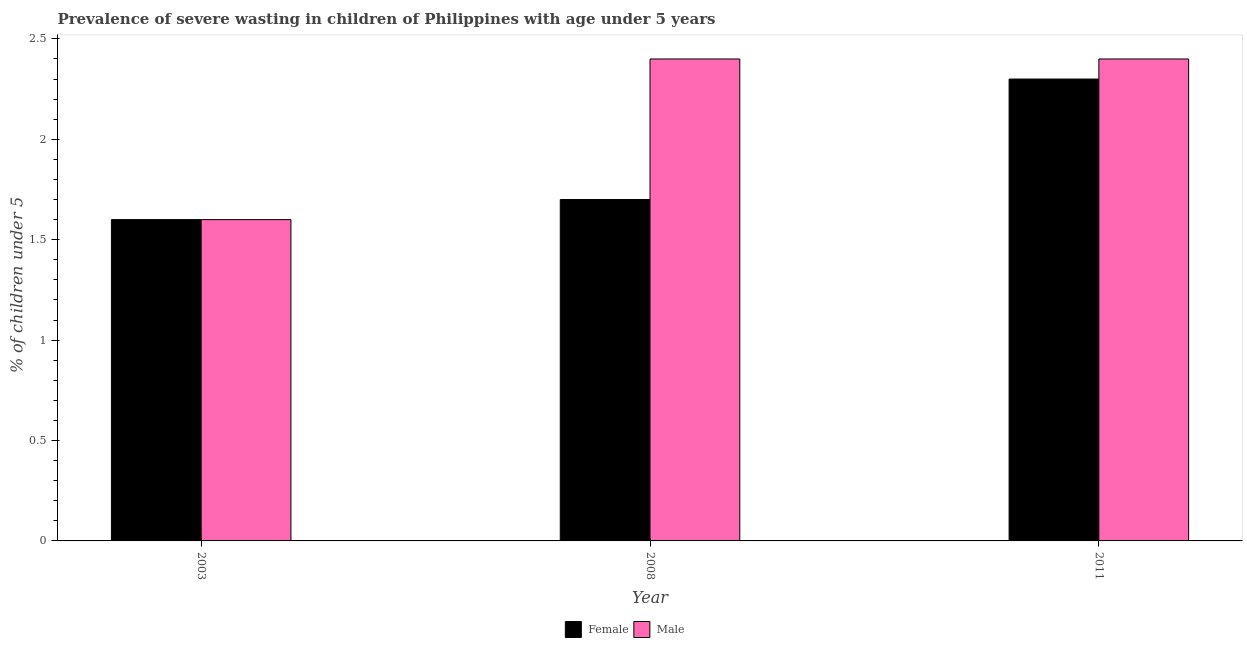Are the number of bars per tick equal to the number of legend labels?
Your response must be concise. Yes. How many bars are there on the 2nd tick from the left?
Offer a terse response. 2. What is the label of the 3rd group of bars from the left?
Your answer should be very brief. 2011. In how many cases, is the number of bars for a given year not equal to the number of legend labels?
Offer a very short reply. 0. What is the percentage of undernourished male children in 2003?
Offer a terse response. 1.6. Across all years, what is the maximum percentage of undernourished female children?
Make the answer very short. 2.3. Across all years, what is the minimum percentage of undernourished male children?
Offer a very short reply. 1.6. In which year was the percentage of undernourished male children minimum?
Keep it short and to the point. 2003. What is the total percentage of undernourished male children in the graph?
Provide a short and direct response. 6.4. What is the difference between the percentage of undernourished female children in 2003 and that in 2008?
Give a very brief answer. -0.1. What is the difference between the percentage of undernourished female children in 2011 and the percentage of undernourished male children in 2003?
Make the answer very short. 0.7. What is the average percentage of undernourished female children per year?
Offer a terse response. 1.87. In the year 2011, what is the difference between the percentage of undernourished female children and percentage of undernourished male children?
Provide a succinct answer. 0. What is the ratio of the percentage of undernourished female children in 2008 to that in 2011?
Keep it short and to the point. 0.74. Is the percentage of undernourished male children in 2008 less than that in 2011?
Provide a short and direct response. No. Is the difference between the percentage of undernourished male children in 2003 and 2011 greater than the difference between the percentage of undernourished female children in 2003 and 2011?
Provide a short and direct response. No. What is the difference between the highest and the lowest percentage of undernourished female children?
Your answer should be very brief. 0.7. In how many years, is the percentage of undernourished male children greater than the average percentage of undernourished male children taken over all years?
Your answer should be very brief. 2. Is the sum of the percentage of undernourished male children in 2003 and 2011 greater than the maximum percentage of undernourished female children across all years?
Offer a very short reply. Yes. What does the 1st bar from the left in 2003 represents?
Your answer should be very brief. Female. What does the 2nd bar from the right in 2008 represents?
Provide a succinct answer. Female. How many bars are there?
Keep it short and to the point. 6. Are all the bars in the graph horizontal?
Provide a short and direct response. No. How many years are there in the graph?
Offer a terse response. 3. Are the values on the major ticks of Y-axis written in scientific E-notation?
Ensure brevity in your answer.  No. Does the graph contain any zero values?
Your answer should be compact. No. Where does the legend appear in the graph?
Keep it short and to the point. Bottom center. What is the title of the graph?
Provide a short and direct response. Prevalence of severe wasting in children of Philippines with age under 5 years. What is the label or title of the X-axis?
Your answer should be very brief. Year. What is the label or title of the Y-axis?
Your answer should be compact.  % of children under 5. What is the  % of children under 5 of Female in 2003?
Your response must be concise. 1.6. What is the  % of children under 5 in Male in 2003?
Keep it short and to the point. 1.6. What is the  % of children under 5 in Female in 2008?
Provide a short and direct response. 1.7. What is the  % of children under 5 in Male in 2008?
Give a very brief answer. 2.4. What is the  % of children under 5 of Female in 2011?
Provide a succinct answer. 2.3. What is the  % of children under 5 of Male in 2011?
Offer a very short reply. 2.4. Across all years, what is the maximum  % of children under 5 in Female?
Make the answer very short. 2.3. Across all years, what is the maximum  % of children under 5 in Male?
Offer a very short reply. 2.4. Across all years, what is the minimum  % of children under 5 of Female?
Your answer should be compact. 1.6. Across all years, what is the minimum  % of children under 5 in Male?
Make the answer very short. 1.6. What is the total  % of children under 5 in Male in the graph?
Give a very brief answer. 6.4. What is the difference between the  % of children under 5 of Female in 2003 and that in 2008?
Your response must be concise. -0.1. What is the difference between the  % of children under 5 of Female in 2003 and that in 2011?
Provide a short and direct response. -0.7. What is the difference between the  % of children under 5 in Male in 2003 and that in 2011?
Keep it short and to the point. -0.8. What is the difference between the  % of children under 5 in Male in 2008 and that in 2011?
Provide a succinct answer. 0. What is the difference between the  % of children under 5 of Female in 2003 and the  % of children under 5 of Male in 2008?
Provide a succinct answer. -0.8. What is the difference between the  % of children under 5 of Female in 2003 and the  % of children under 5 of Male in 2011?
Make the answer very short. -0.8. What is the difference between the  % of children under 5 of Female in 2008 and the  % of children under 5 of Male in 2011?
Ensure brevity in your answer.  -0.7. What is the average  % of children under 5 in Female per year?
Your response must be concise. 1.87. What is the average  % of children under 5 in Male per year?
Offer a terse response. 2.13. In the year 2003, what is the difference between the  % of children under 5 of Female and  % of children under 5 of Male?
Give a very brief answer. 0. What is the ratio of the  % of children under 5 in Female in 2003 to that in 2008?
Your response must be concise. 0.94. What is the ratio of the  % of children under 5 of Female in 2003 to that in 2011?
Provide a succinct answer. 0.7. What is the ratio of the  % of children under 5 of Female in 2008 to that in 2011?
Your answer should be compact. 0.74. What is the ratio of the  % of children under 5 in Male in 2008 to that in 2011?
Your answer should be very brief. 1. What is the difference between the highest and the second highest  % of children under 5 in Female?
Your answer should be very brief. 0.6. What is the difference between the highest and the second highest  % of children under 5 of Male?
Offer a very short reply. 0. What is the difference between the highest and the lowest  % of children under 5 in Female?
Make the answer very short. 0.7. 